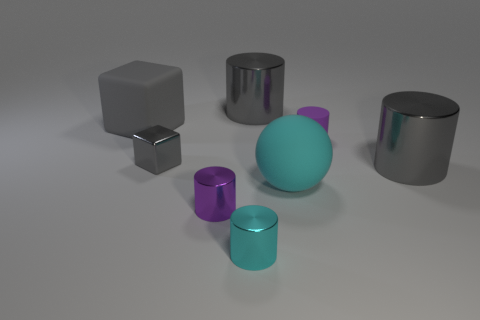What is the shape of the small matte object? cylinder 